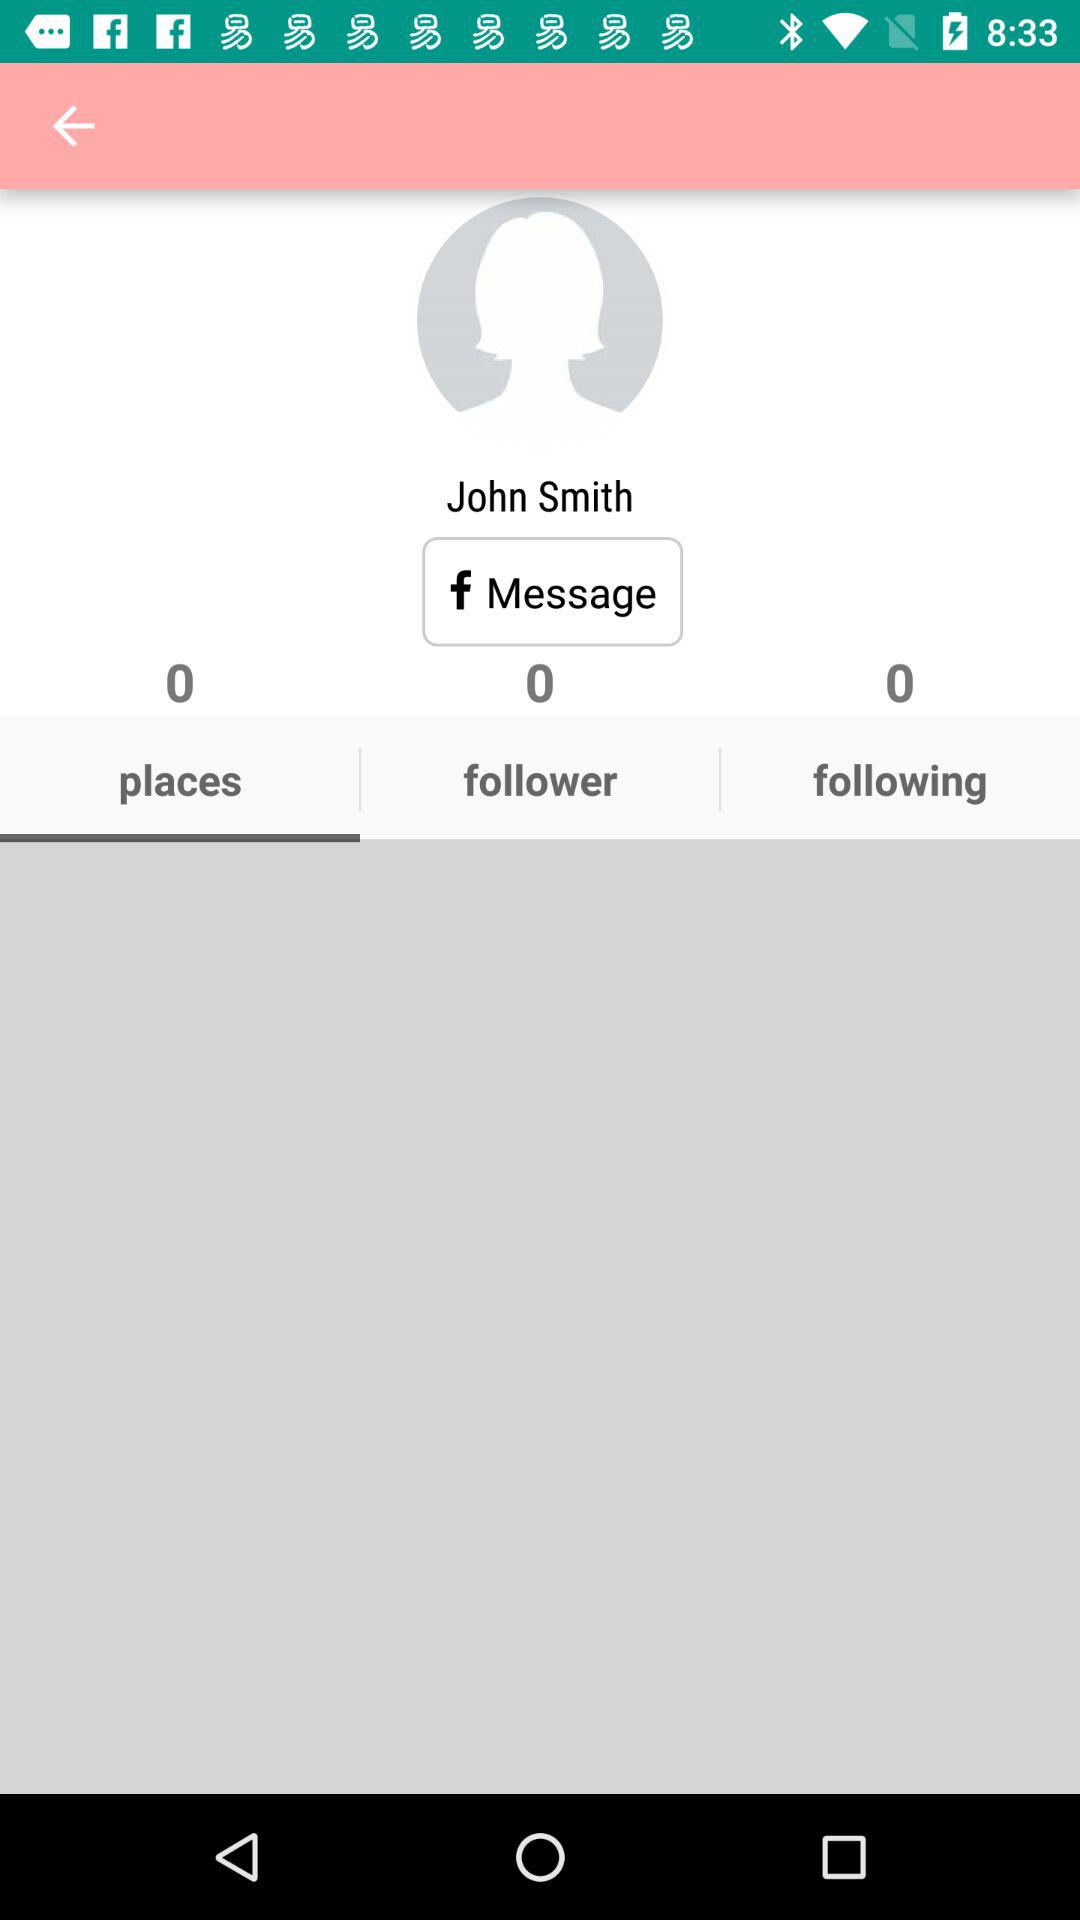How many followers does John Smith have? John Smith has 0 followers. 